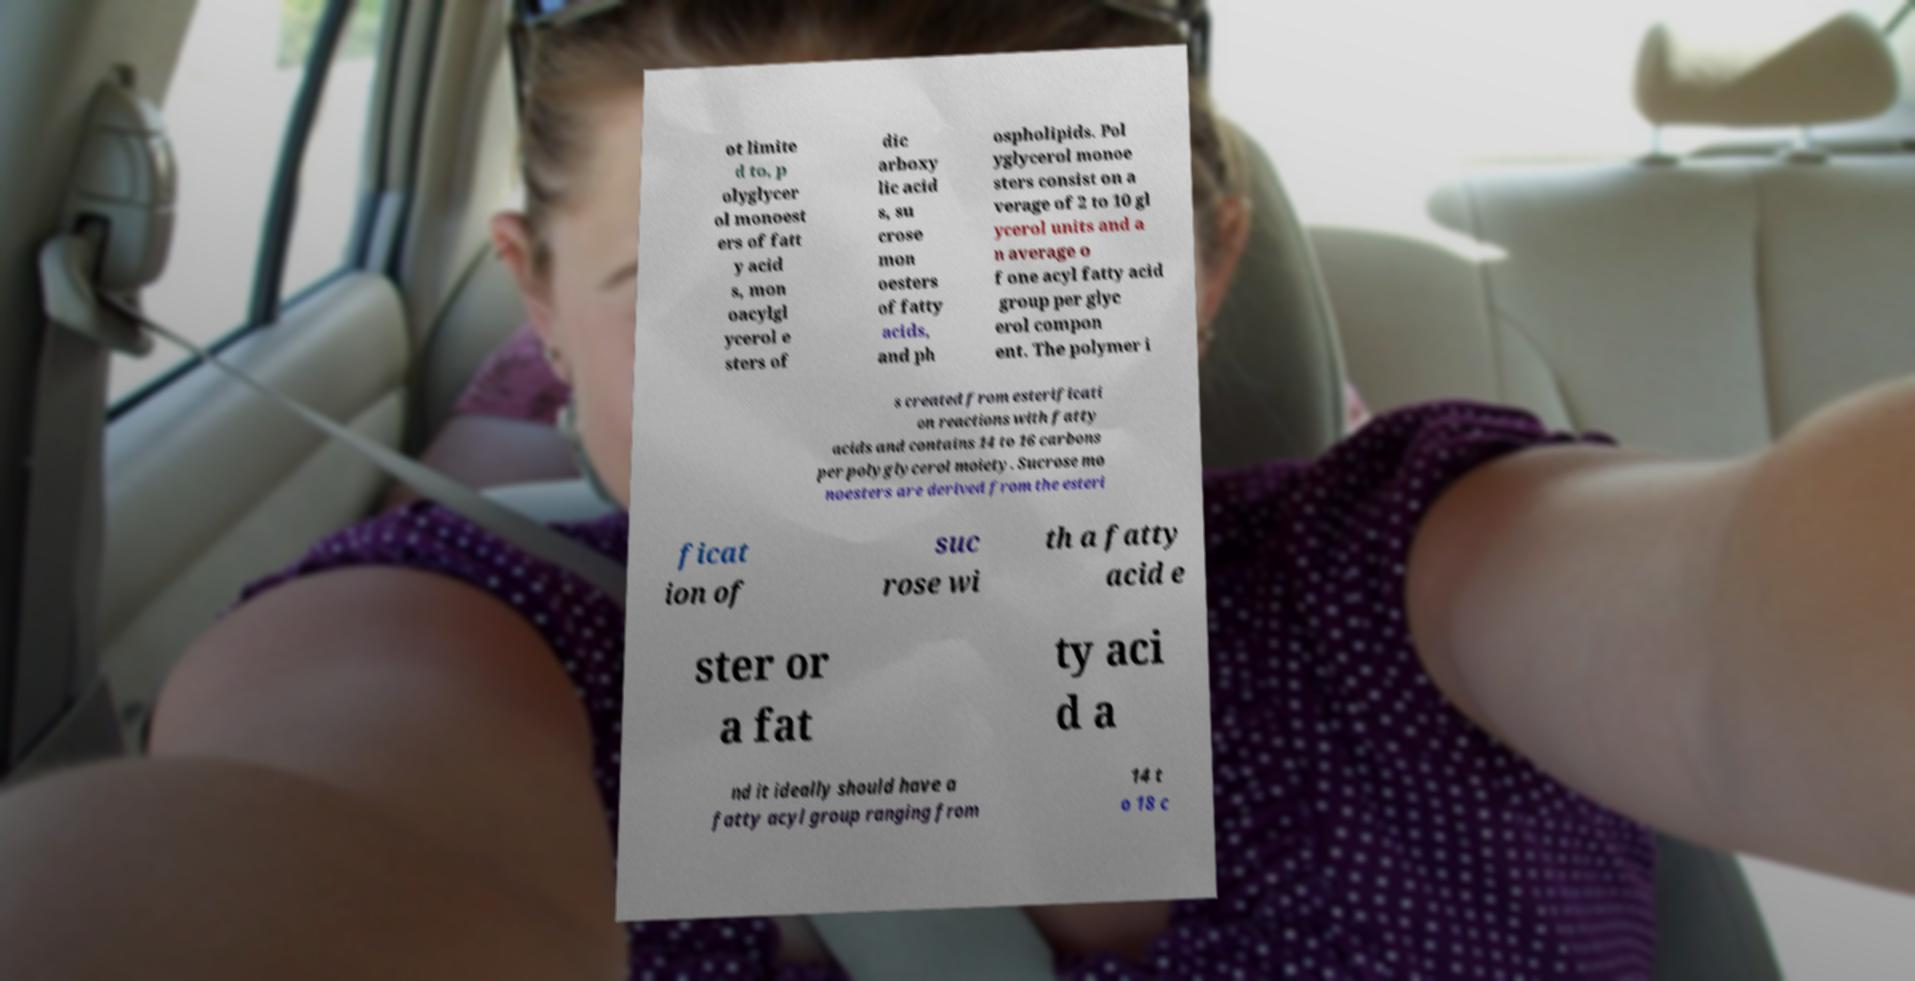I need the written content from this picture converted into text. Can you do that? ot limite d to, p olyglycer ol monoest ers of fatt y acid s, mon oacylgl ycerol e sters of dic arboxy lic acid s, su crose mon oesters of fatty acids, and ph ospholipids. Pol yglycerol monoe sters consist on a verage of 2 to 10 gl ycerol units and a n average o f one acyl fatty acid group per glyc erol compon ent. The polymer i s created from esterificati on reactions with fatty acids and contains 14 to 16 carbons per polyglycerol moiety. Sucrose mo noesters are derived from the esteri ficat ion of suc rose wi th a fatty acid e ster or a fat ty aci d a nd it ideally should have a fatty acyl group ranging from 14 t o 18 c 